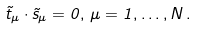<formula> <loc_0><loc_0><loc_500><loc_500>\vec { t } _ { \mu } \cdot \vec { s } _ { \mu } = 0 , \, \mu = 1 , \dots , N \, .</formula> 